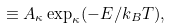Convert formula to latex. <formula><loc_0><loc_0><loc_500><loc_500>\equiv A _ { \kappa } \exp _ { \kappa } ( - E / k _ { B } T ) ,</formula> 